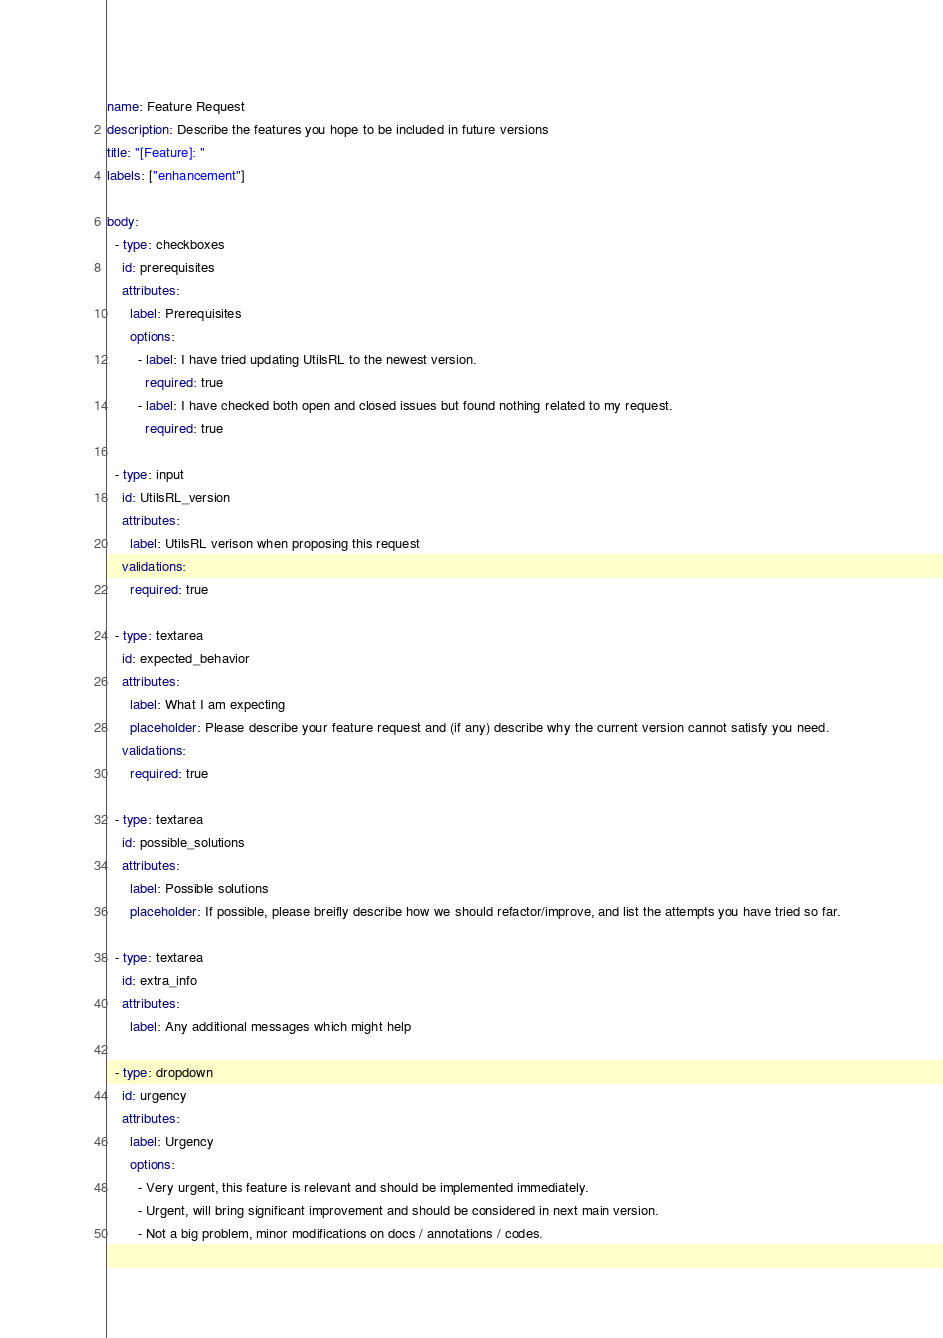Convert code to text. <code><loc_0><loc_0><loc_500><loc_500><_YAML_>name: Feature Request
description: Describe the features you hope to be included in future versions
title: "[Feature]: "
labels: ["enhancement"]

body: 
  - type: checkboxes
    id: prerequisites
    attributes: 
      label: Prerequisites
      options: 
        - label: I have tried updating UtilsRL to the newest version.
          required: true
        - label: I have checked both open and closed issues but found nothing related to my request. 
          required: true

  - type: input
    id: UtilsRL_version
    attributes: 
      label: UtilsRL verison when proposing this request
    validations:
      required: true

  - type: textarea
    id: expected_behavior
    attributes: 
      label: What I am expecting
      placeholder: Please describe your feature request and (if any) describe why the current version cannot satisfy you need.
    validations: 
      required: true
  
  - type: textarea
    id: possible_solutions
    attributes: 
      label: Possible solutions
      placeholder: If possible, please breifly describe how we should refactor/improve, and list the attempts you have tried so far.  
  
  - type: textarea
    id: extra_info
    attributes: 
      label: Any additional messages which might help
      
  - type: dropdown
    id: urgency
    attributes: 
      label: Urgency
      options: 
        - Very urgent, this feature is relevant and should be implemented immediately.
        - Urgent, will bring significant improvement and should be considered in next main version.
        - Not a big problem, minor modifications on docs / annotations / codes.
</code> 